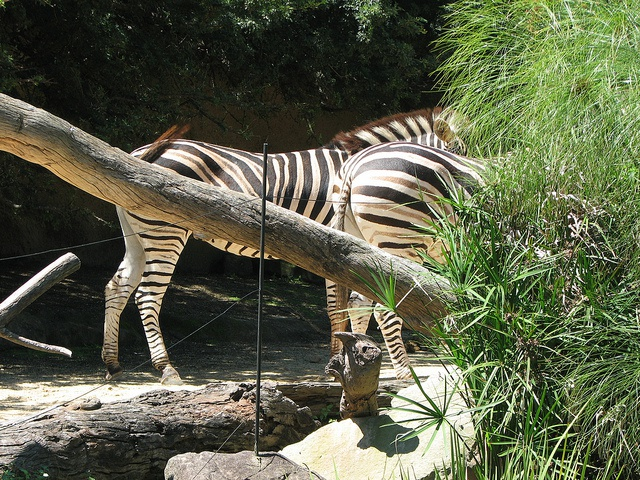Describe the objects in this image and their specific colors. I can see zebra in lightgreen, black, ivory, gray, and tan tones and zebra in lightgreen, white, darkgray, black, and tan tones in this image. 